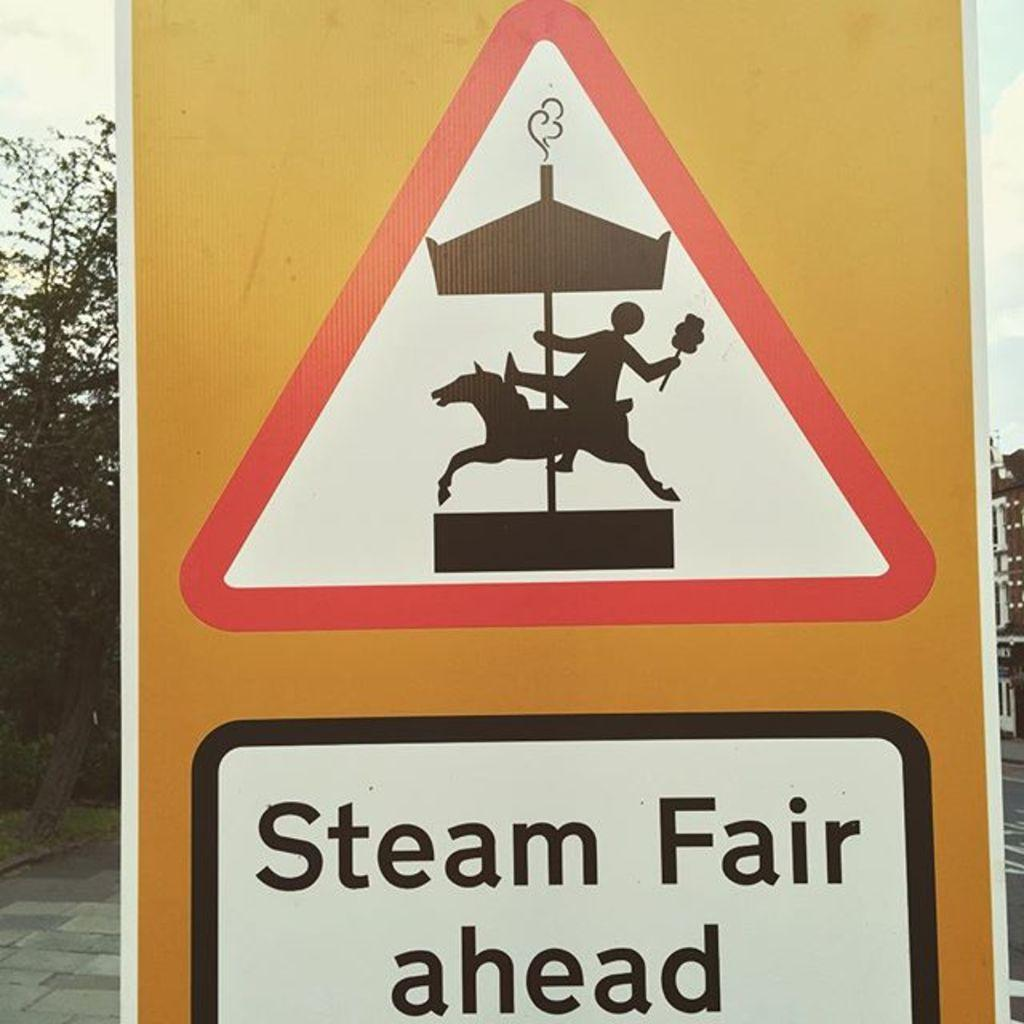<image>
Render a clear and concise summary of the photo. the words steam fair ahead that are on a sign 